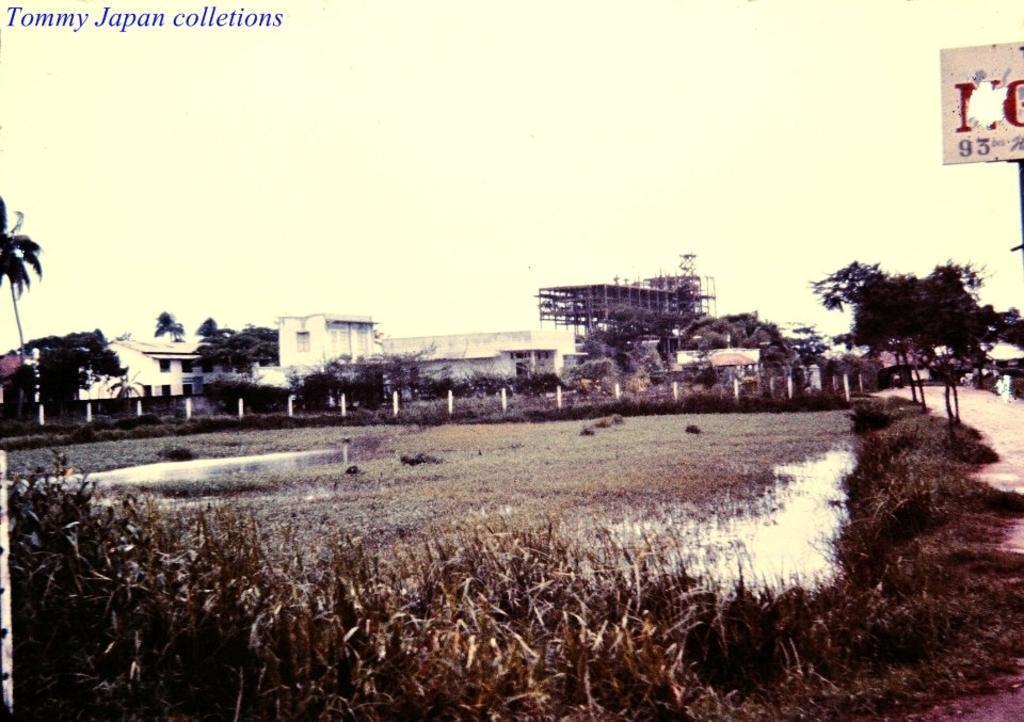Could you give a brief overview of what you see in this image? In the picture I can see the water, the grass, trees, buildings, poles, a board and the sky. On the top left corner of the image I can see a watermark. 